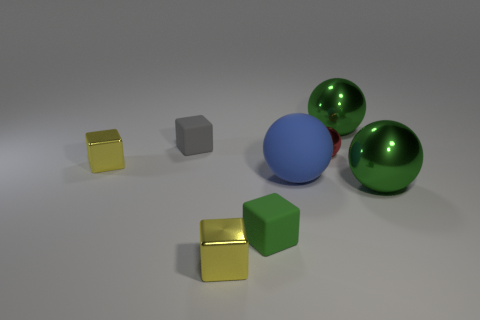Subtract all large blue balls. How many balls are left? 3 Subtract all green cylinders. How many yellow cubes are left? 2 Add 2 tiny gray objects. How many objects exist? 10 Subtract 2 blocks. How many blocks are left? 2 Subtract all blue spheres. How many spheres are left? 3 Subtract all blue things. Subtract all big yellow rubber spheres. How many objects are left? 7 Add 8 gray blocks. How many gray blocks are left? 9 Add 3 tiny gray objects. How many tiny gray objects exist? 4 Subtract 0 brown balls. How many objects are left? 8 Subtract all brown cubes. Subtract all yellow spheres. How many cubes are left? 4 